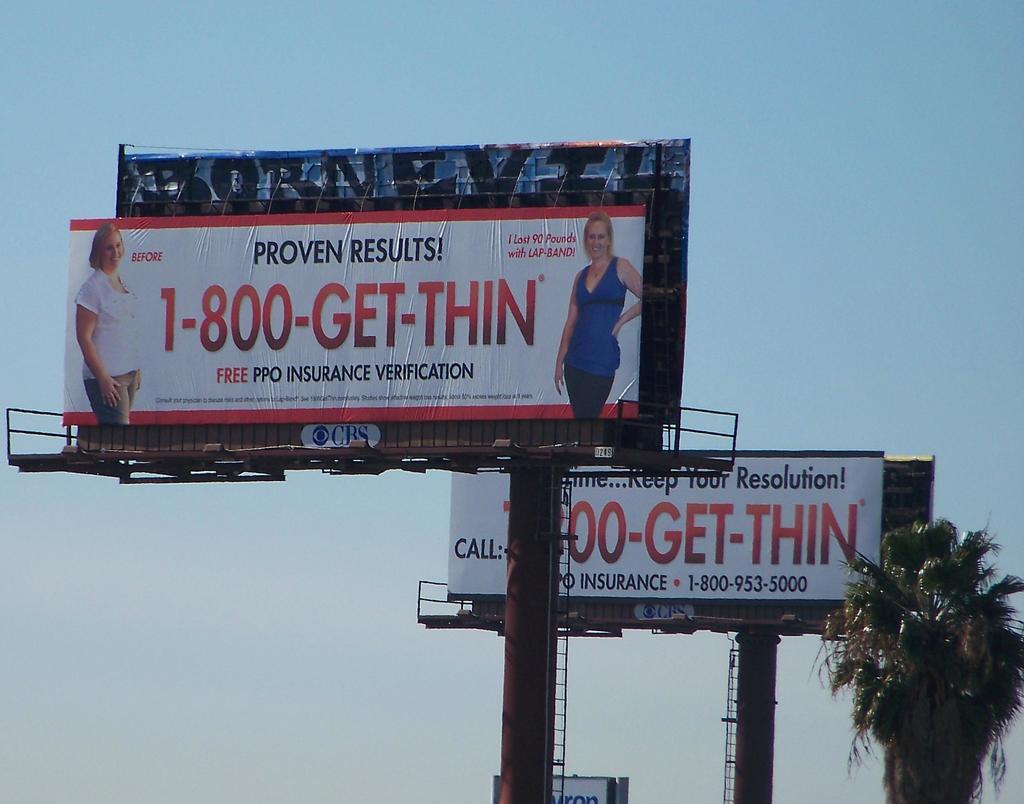How much does it cost for the services advertised?
Your response must be concise. Free. What is the phone number on the billboard?
Keep it short and to the point. 1-800-get-thin. 